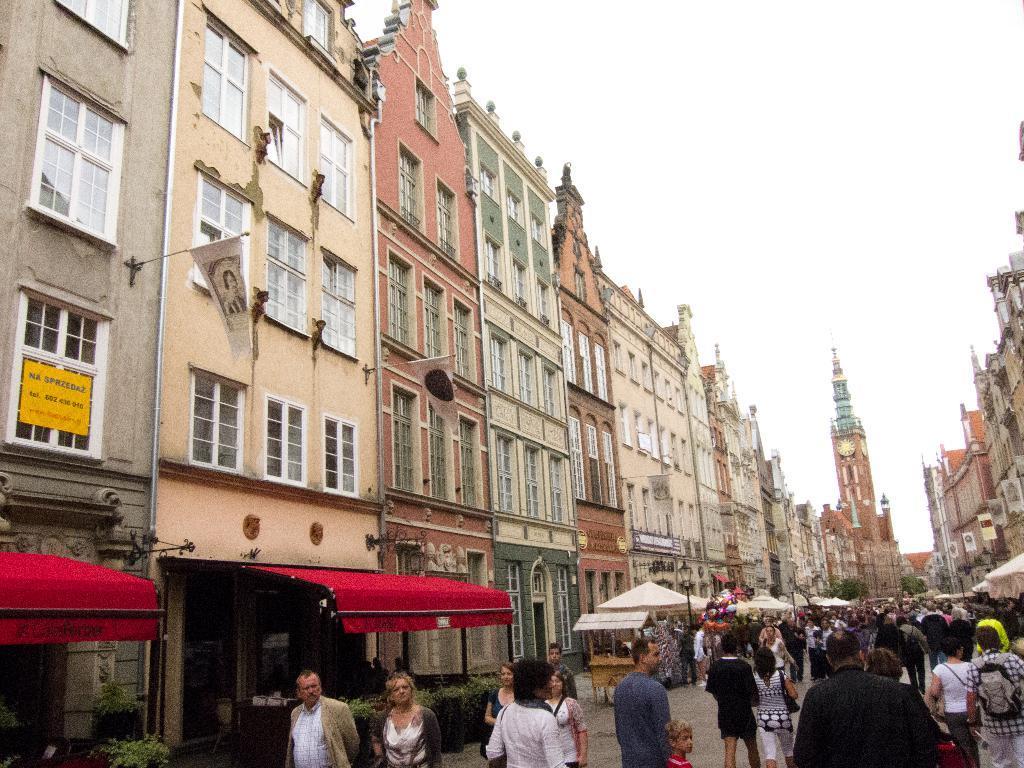Could you give a brief overview of what you see in this image? In this image we can see a group of people walking on the road. Here we can see the buildings on the left side and the right side as well. Here we can see the tents on the side of a road. Here we can see the clock tower. 